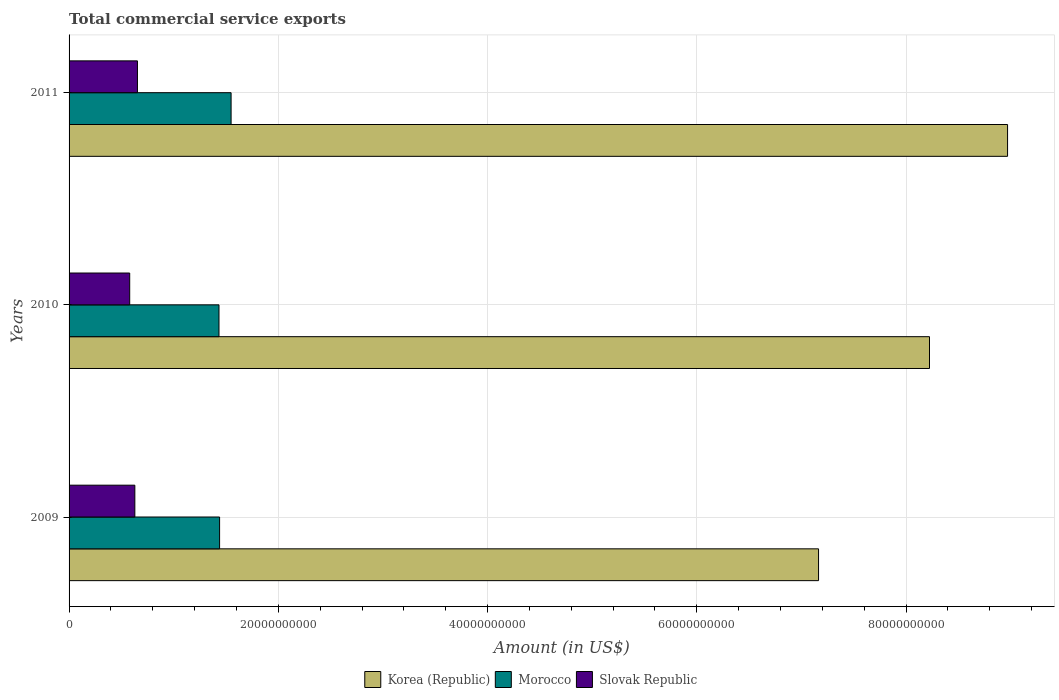How many different coloured bars are there?
Ensure brevity in your answer.  3. How many groups of bars are there?
Provide a succinct answer. 3. Are the number of bars per tick equal to the number of legend labels?
Your response must be concise. Yes. How many bars are there on the 2nd tick from the top?
Your answer should be very brief. 3. In how many cases, is the number of bars for a given year not equal to the number of legend labels?
Ensure brevity in your answer.  0. What is the total commercial service exports in Morocco in 2009?
Keep it short and to the point. 1.44e+1. Across all years, what is the maximum total commercial service exports in Morocco?
Make the answer very short. 1.55e+1. Across all years, what is the minimum total commercial service exports in Morocco?
Provide a succinct answer. 1.43e+1. What is the total total commercial service exports in Korea (Republic) in the graph?
Your answer should be very brief. 2.44e+11. What is the difference between the total commercial service exports in Korea (Republic) in 2009 and that in 2010?
Ensure brevity in your answer.  -1.06e+1. What is the difference between the total commercial service exports in Slovak Republic in 2010 and the total commercial service exports in Korea (Republic) in 2011?
Provide a short and direct response. -8.39e+1. What is the average total commercial service exports in Morocco per year?
Your answer should be very brief. 1.47e+1. In the year 2010, what is the difference between the total commercial service exports in Morocco and total commercial service exports in Slovak Republic?
Offer a terse response. 8.53e+09. In how many years, is the total commercial service exports in Korea (Republic) greater than 16000000000 US$?
Provide a short and direct response. 3. What is the ratio of the total commercial service exports in Slovak Republic in 2010 to that in 2011?
Your answer should be very brief. 0.89. Is the total commercial service exports in Korea (Republic) in 2009 less than that in 2010?
Give a very brief answer. Yes. Is the difference between the total commercial service exports in Morocco in 2009 and 2011 greater than the difference between the total commercial service exports in Slovak Republic in 2009 and 2011?
Provide a succinct answer. No. What is the difference between the highest and the second highest total commercial service exports in Slovak Republic?
Provide a short and direct response. 2.50e+08. What is the difference between the highest and the lowest total commercial service exports in Morocco?
Make the answer very short. 1.16e+09. Is the sum of the total commercial service exports in Korea (Republic) in 2010 and 2011 greater than the maximum total commercial service exports in Morocco across all years?
Your answer should be compact. Yes. How many bars are there?
Offer a terse response. 9. How many years are there in the graph?
Your answer should be compact. 3. Does the graph contain any zero values?
Your response must be concise. No. Does the graph contain grids?
Ensure brevity in your answer.  Yes. Where does the legend appear in the graph?
Keep it short and to the point. Bottom center. How many legend labels are there?
Ensure brevity in your answer.  3. How are the legend labels stacked?
Keep it short and to the point. Horizontal. What is the title of the graph?
Your answer should be very brief. Total commercial service exports. What is the label or title of the X-axis?
Provide a short and direct response. Amount (in US$). What is the label or title of the Y-axis?
Your response must be concise. Years. What is the Amount (in US$) of Korea (Republic) in 2009?
Your answer should be very brief. 7.16e+1. What is the Amount (in US$) of Morocco in 2009?
Ensure brevity in your answer.  1.44e+1. What is the Amount (in US$) of Slovak Republic in 2009?
Your answer should be compact. 6.29e+09. What is the Amount (in US$) in Korea (Republic) in 2010?
Your answer should be compact. 8.22e+1. What is the Amount (in US$) in Morocco in 2010?
Offer a terse response. 1.43e+1. What is the Amount (in US$) of Slovak Republic in 2010?
Make the answer very short. 5.80e+09. What is the Amount (in US$) of Korea (Republic) in 2011?
Your answer should be compact. 8.97e+1. What is the Amount (in US$) in Morocco in 2011?
Your answer should be compact. 1.55e+1. What is the Amount (in US$) in Slovak Republic in 2011?
Keep it short and to the point. 6.54e+09. Across all years, what is the maximum Amount (in US$) of Korea (Republic)?
Give a very brief answer. 8.97e+1. Across all years, what is the maximum Amount (in US$) in Morocco?
Make the answer very short. 1.55e+1. Across all years, what is the maximum Amount (in US$) in Slovak Republic?
Keep it short and to the point. 6.54e+09. Across all years, what is the minimum Amount (in US$) of Korea (Republic)?
Offer a very short reply. 7.16e+1. Across all years, what is the minimum Amount (in US$) of Morocco?
Provide a short and direct response. 1.43e+1. Across all years, what is the minimum Amount (in US$) in Slovak Republic?
Ensure brevity in your answer.  5.80e+09. What is the total Amount (in US$) of Korea (Republic) in the graph?
Provide a succinct answer. 2.44e+11. What is the total Amount (in US$) in Morocco in the graph?
Give a very brief answer. 4.42e+1. What is the total Amount (in US$) of Slovak Republic in the graph?
Give a very brief answer. 1.86e+1. What is the difference between the Amount (in US$) of Korea (Republic) in 2009 and that in 2010?
Offer a very short reply. -1.06e+1. What is the difference between the Amount (in US$) in Morocco in 2009 and that in 2010?
Your answer should be compact. 5.92e+07. What is the difference between the Amount (in US$) in Slovak Republic in 2009 and that in 2010?
Provide a short and direct response. 4.91e+08. What is the difference between the Amount (in US$) of Korea (Republic) in 2009 and that in 2011?
Your response must be concise. -1.81e+1. What is the difference between the Amount (in US$) of Morocco in 2009 and that in 2011?
Make the answer very short. -1.10e+09. What is the difference between the Amount (in US$) of Slovak Republic in 2009 and that in 2011?
Make the answer very short. -2.50e+08. What is the difference between the Amount (in US$) of Korea (Republic) in 2010 and that in 2011?
Provide a succinct answer. -7.46e+09. What is the difference between the Amount (in US$) in Morocco in 2010 and that in 2011?
Give a very brief answer. -1.16e+09. What is the difference between the Amount (in US$) of Slovak Republic in 2010 and that in 2011?
Ensure brevity in your answer.  -7.41e+08. What is the difference between the Amount (in US$) in Korea (Republic) in 2009 and the Amount (in US$) in Morocco in 2010?
Make the answer very short. 5.73e+1. What is the difference between the Amount (in US$) in Korea (Republic) in 2009 and the Amount (in US$) in Slovak Republic in 2010?
Provide a succinct answer. 6.58e+1. What is the difference between the Amount (in US$) of Morocco in 2009 and the Amount (in US$) of Slovak Republic in 2010?
Ensure brevity in your answer.  8.59e+09. What is the difference between the Amount (in US$) in Korea (Republic) in 2009 and the Amount (in US$) in Morocco in 2011?
Ensure brevity in your answer.  5.62e+1. What is the difference between the Amount (in US$) in Korea (Republic) in 2009 and the Amount (in US$) in Slovak Republic in 2011?
Ensure brevity in your answer.  6.51e+1. What is the difference between the Amount (in US$) of Morocco in 2009 and the Amount (in US$) of Slovak Republic in 2011?
Your answer should be very brief. 7.85e+09. What is the difference between the Amount (in US$) in Korea (Republic) in 2010 and the Amount (in US$) in Morocco in 2011?
Your response must be concise. 6.68e+1. What is the difference between the Amount (in US$) of Korea (Republic) in 2010 and the Amount (in US$) of Slovak Republic in 2011?
Make the answer very short. 7.57e+1. What is the difference between the Amount (in US$) of Morocco in 2010 and the Amount (in US$) of Slovak Republic in 2011?
Keep it short and to the point. 7.79e+09. What is the average Amount (in US$) of Korea (Republic) per year?
Give a very brief answer. 8.12e+1. What is the average Amount (in US$) of Morocco per year?
Provide a short and direct response. 1.47e+1. What is the average Amount (in US$) of Slovak Republic per year?
Ensure brevity in your answer.  6.21e+09. In the year 2009, what is the difference between the Amount (in US$) of Korea (Republic) and Amount (in US$) of Morocco?
Provide a short and direct response. 5.72e+1. In the year 2009, what is the difference between the Amount (in US$) in Korea (Republic) and Amount (in US$) in Slovak Republic?
Provide a succinct answer. 6.54e+1. In the year 2009, what is the difference between the Amount (in US$) in Morocco and Amount (in US$) in Slovak Republic?
Your answer should be compact. 8.10e+09. In the year 2010, what is the difference between the Amount (in US$) in Korea (Republic) and Amount (in US$) in Morocco?
Give a very brief answer. 6.79e+1. In the year 2010, what is the difference between the Amount (in US$) of Korea (Republic) and Amount (in US$) of Slovak Republic?
Your answer should be compact. 7.64e+1. In the year 2010, what is the difference between the Amount (in US$) in Morocco and Amount (in US$) in Slovak Republic?
Your answer should be very brief. 8.53e+09. In the year 2011, what is the difference between the Amount (in US$) in Korea (Republic) and Amount (in US$) in Morocco?
Keep it short and to the point. 7.42e+1. In the year 2011, what is the difference between the Amount (in US$) of Korea (Republic) and Amount (in US$) of Slovak Republic?
Keep it short and to the point. 8.32e+1. In the year 2011, what is the difference between the Amount (in US$) in Morocco and Amount (in US$) in Slovak Republic?
Your response must be concise. 8.95e+09. What is the ratio of the Amount (in US$) of Korea (Republic) in 2009 to that in 2010?
Ensure brevity in your answer.  0.87. What is the ratio of the Amount (in US$) in Morocco in 2009 to that in 2010?
Provide a succinct answer. 1. What is the ratio of the Amount (in US$) in Slovak Republic in 2009 to that in 2010?
Your response must be concise. 1.08. What is the ratio of the Amount (in US$) in Korea (Republic) in 2009 to that in 2011?
Make the answer very short. 0.8. What is the ratio of the Amount (in US$) of Morocco in 2009 to that in 2011?
Ensure brevity in your answer.  0.93. What is the ratio of the Amount (in US$) in Slovak Republic in 2009 to that in 2011?
Your answer should be very brief. 0.96. What is the ratio of the Amount (in US$) in Korea (Republic) in 2010 to that in 2011?
Offer a very short reply. 0.92. What is the ratio of the Amount (in US$) in Morocco in 2010 to that in 2011?
Ensure brevity in your answer.  0.93. What is the ratio of the Amount (in US$) of Slovak Republic in 2010 to that in 2011?
Your response must be concise. 0.89. What is the difference between the highest and the second highest Amount (in US$) in Korea (Republic)?
Make the answer very short. 7.46e+09. What is the difference between the highest and the second highest Amount (in US$) of Morocco?
Keep it short and to the point. 1.10e+09. What is the difference between the highest and the second highest Amount (in US$) in Slovak Republic?
Provide a short and direct response. 2.50e+08. What is the difference between the highest and the lowest Amount (in US$) in Korea (Republic)?
Give a very brief answer. 1.81e+1. What is the difference between the highest and the lowest Amount (in US$) in Morocco?
Provide a short and direct response. 1.16e+09. What is the difference between the highest and the lowest Amount (in US$) in Slovak Republic?
Your answer should be very brief. 7.41e+08. 